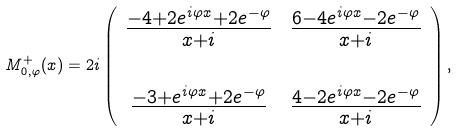<formula> <loc_0><loc_0><loc_500><loc_500>M _ { 0 , \varphi } ^ { + } ( x ) = 2 i \left ( \begin{array} { c c } \frac { - 4 + 2 e ^ { i \varphi x } + 2 e ^ { - \varphi } } { x + i } & \frac { 6 - 4 e ^ { i \varphi x } - 2 e ^ { - \varphi } } { x + i } \\ & \\ \frac { - 3 + e ^ { i \varphi x } + 2 e ^ { - \varphi } } { x + i } & \frac { 4 - 2 e ^ { i \varphi x } - 2 e ^ { - \varphi } } { x + i } \end{array} \right ) ,</formula> 